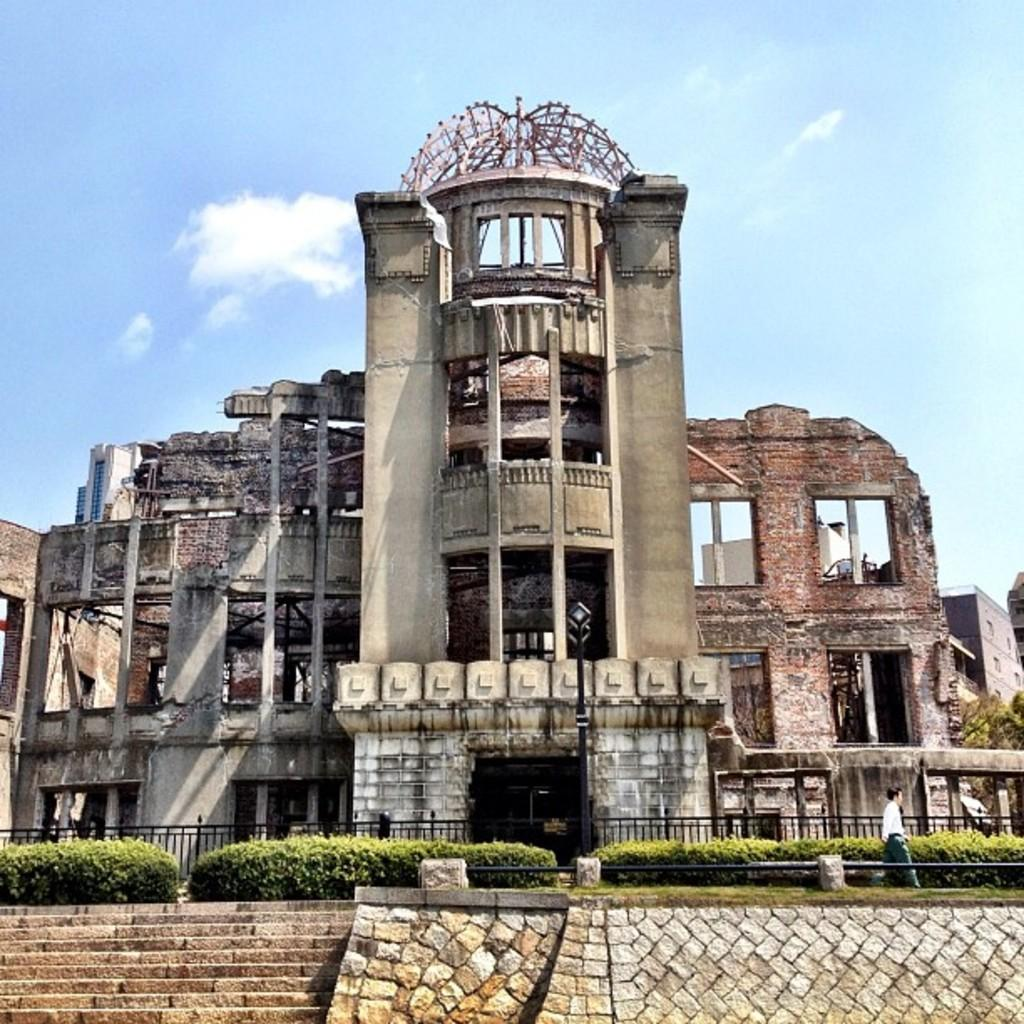What type of structure is present in the image? There is a building in the image. What architectural feature can be seen in the image? There are steps in the image. What type of vegetation is visible in the image? There are plants in the image. What can be seen in the sky at the top of the image? There are clouds visible in the sky at the top of the image. What type of machine is being used to generate the laughter in the image? There is no machine or laughter present in the image. 